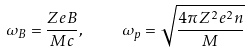<formula> <loc_0><loc_0><loc_500><loc_500>\omega _ { B } = \frac { Z e B } { M c } , \quad \omega _ { p } = \sqrt { \frac { 4 \pi Z ^ { 2 } e ^ { 2 } n } { M } }</formula> 